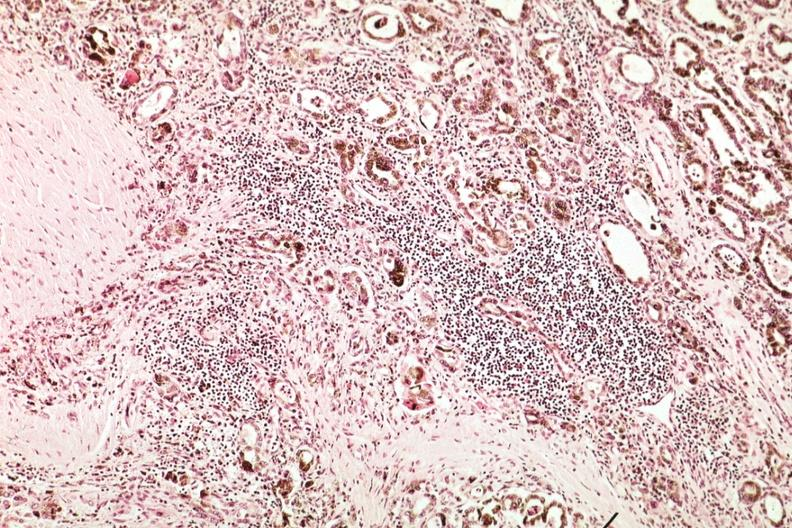where is this part in the figure?
Answer the question using a single word or phrase. Endocrine system 